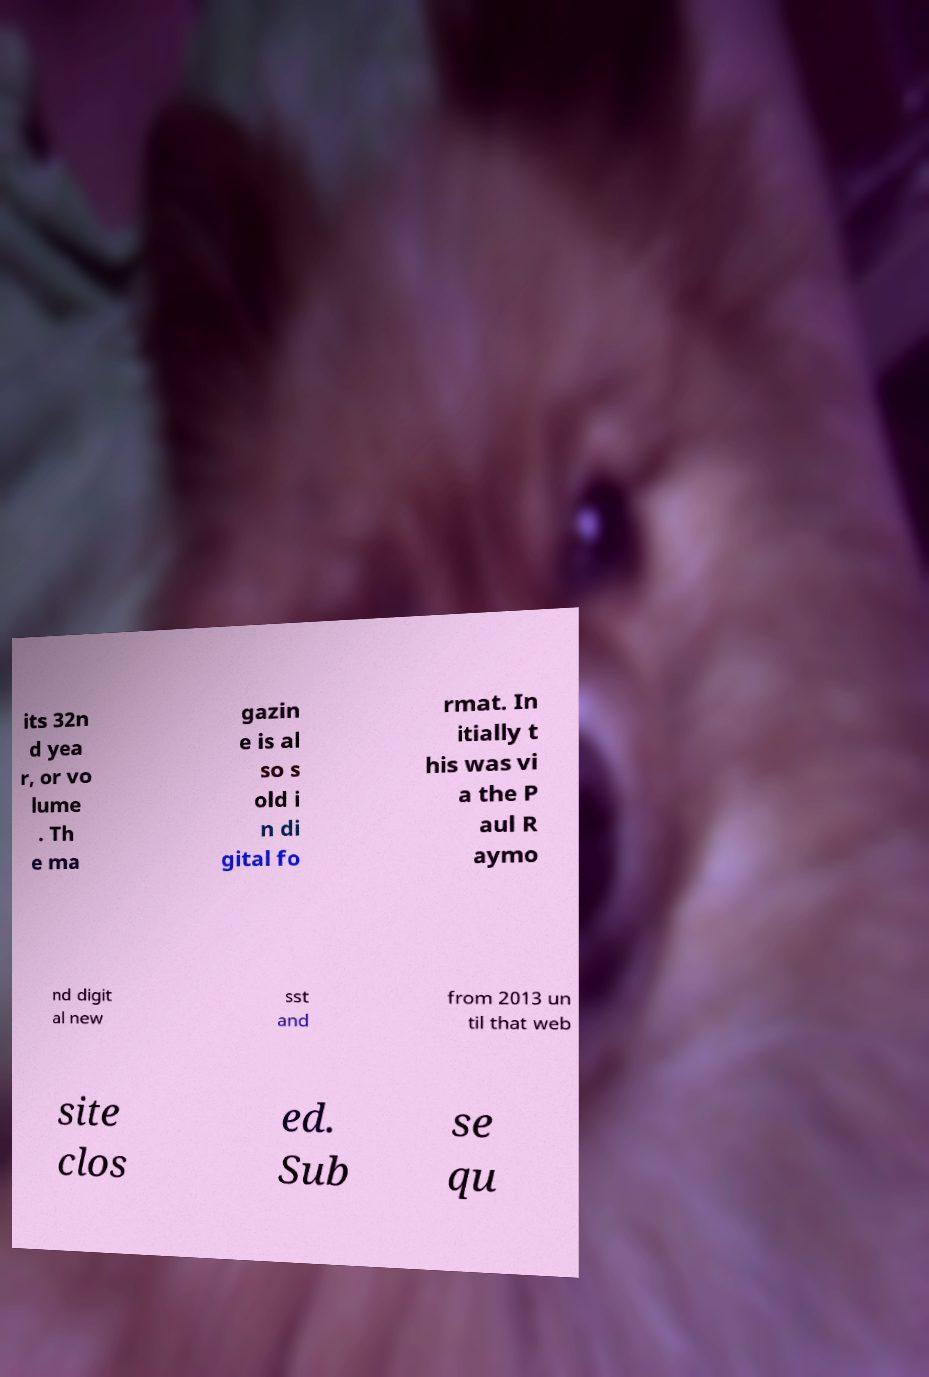Could you assist in decoding the text presented in this image and type it out clearly? its 32n d yea r, or vo lume . Th e ma gazin e is al so s old i n di gital fo rmat. In itially t his was vi a the P aul R aymo nd digit al new sst and from 2013 un til that web site clos ed. Sub se qu 